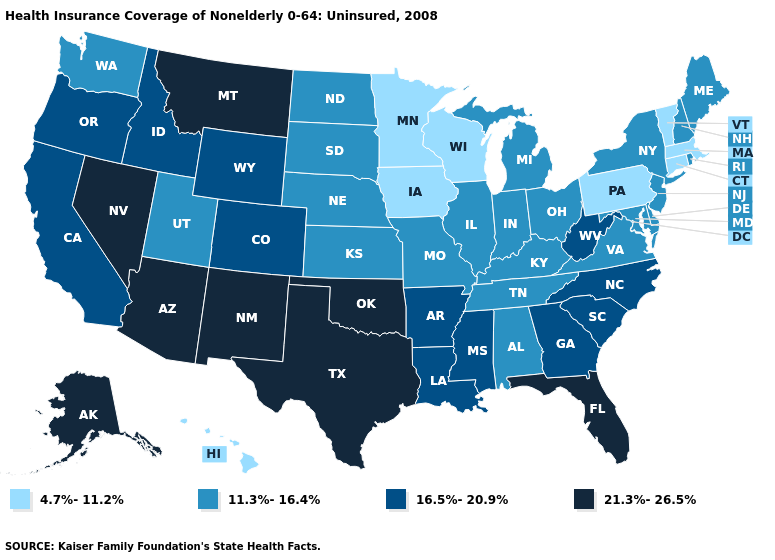What is the value of Kentucky?
Short answer required. 11.3%-16.4%. Among the states that border Pennsylvania , does West Virginia have the highest value?
Be succinct. Yes. Which states have the lowest value in the USA?
Write a very short answer. Connecticut, Hawaii, Iowa, Massachusetts, Minnesota, Pennsylvania, Vermont, Wisconsin. How many symbols are there in the legend?
Be succinct. 4. Name the states that have a value in the range 16.5%-20.9%?
Keep it brief. Arkansas, California, Colorado, Georgia, Idaho, Louisiana, Mississippi, North Carolina, Oregon, South Carolina, West Virginia, Wyoming. What is the value of Kentucky?
Be succinct. 11.3%-16.4%. Among the states that border Texas , does Oklahoma have the highest value?
Keep it brief. Yes. Name the states that have a value in the range 11.3%-16.4%?
Concise answer only. Alabama, Delaware, Illinois, Indiana, Kansas, Kentucky, Maine, Maryland, Michigan, Missouri, Nebraska, New Hampshire, New Jersey, New York, North Dakota, Ohio, Rhode Island, South Dakota, Tennessee, Utah, Virginia, Washington. Does the map have missing data?
Be succinct. No. Which states hav the highest value in the MidWest?
Give a very brief answer. Illinois, Indiana, Kansas, Michigan, Missouri, Nebraska, North Dakota, Ohio, South Dakota. What is the value of Kentucky?
Write a very short answer. 11.3%-16.4%. Which states have the lowest value in the Northeast?
Give a very brief answer. Connecticut, Massachusetts, Pennsylvania, Vermont. What is the value of Vermont?
Concise answer only. 4.7%-11.2%. What is the lowest value in the USA?
Keep it brief. 4.7%-11.2%. Among the states that border Missouri , does Iowa have the highest value?
Short answer required. No. 